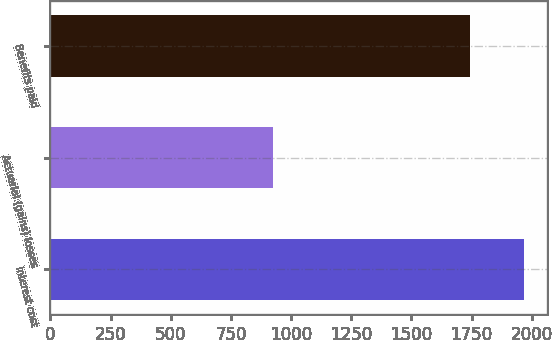Convert chart. <chart><loc_0><loc_0><loc_500><loc_500><bar_chart><fcel>Interest cost<fcel>Actuarial (gains) losses<fcel>Benefits paid<nl><fcel>1966<fcel>925<fcel>1743<nl></chart> 